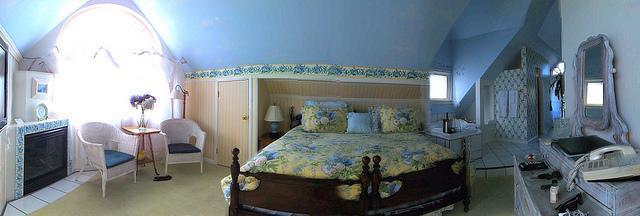How many beds are in this room?
Give a very brief answer. 1. How many people in this photo?
Give a very brief answer. 0. 